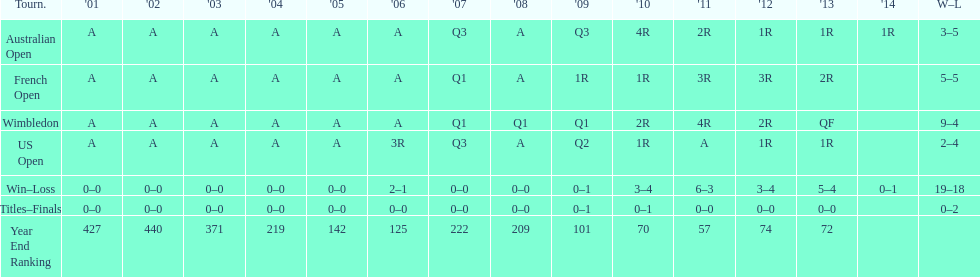Which years was a ranking below 200 achieved? 2005, 2006, 2009, 2010, 2011, 2012, 2013. 